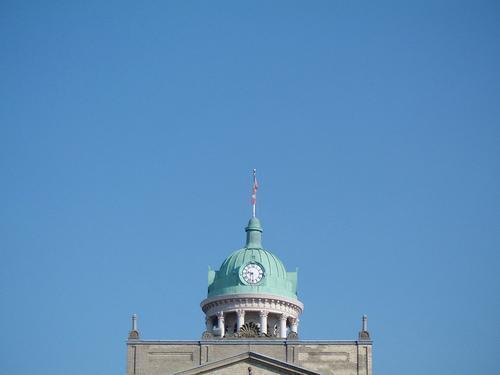How many clocks are there?
Give a very brief answer. 1. 